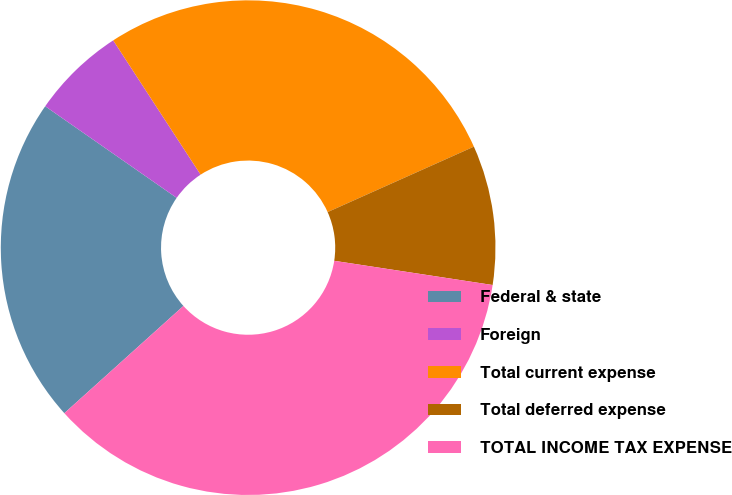Convert chart to OTSL. <chart><loc_0><loc_0><loc_500><loc_500><pie_chart><fcel>Federal & state<fcel>Foreign<fcel>Total current expense<fcel>Total deferred expense<fcel>TOTAL INCOME TAX EXPENSE<nl><fcel>21.36%<fcel>6.13%<fcel>27.49%<fcel>9.11%<fcel>35.92%<nl></chart> 